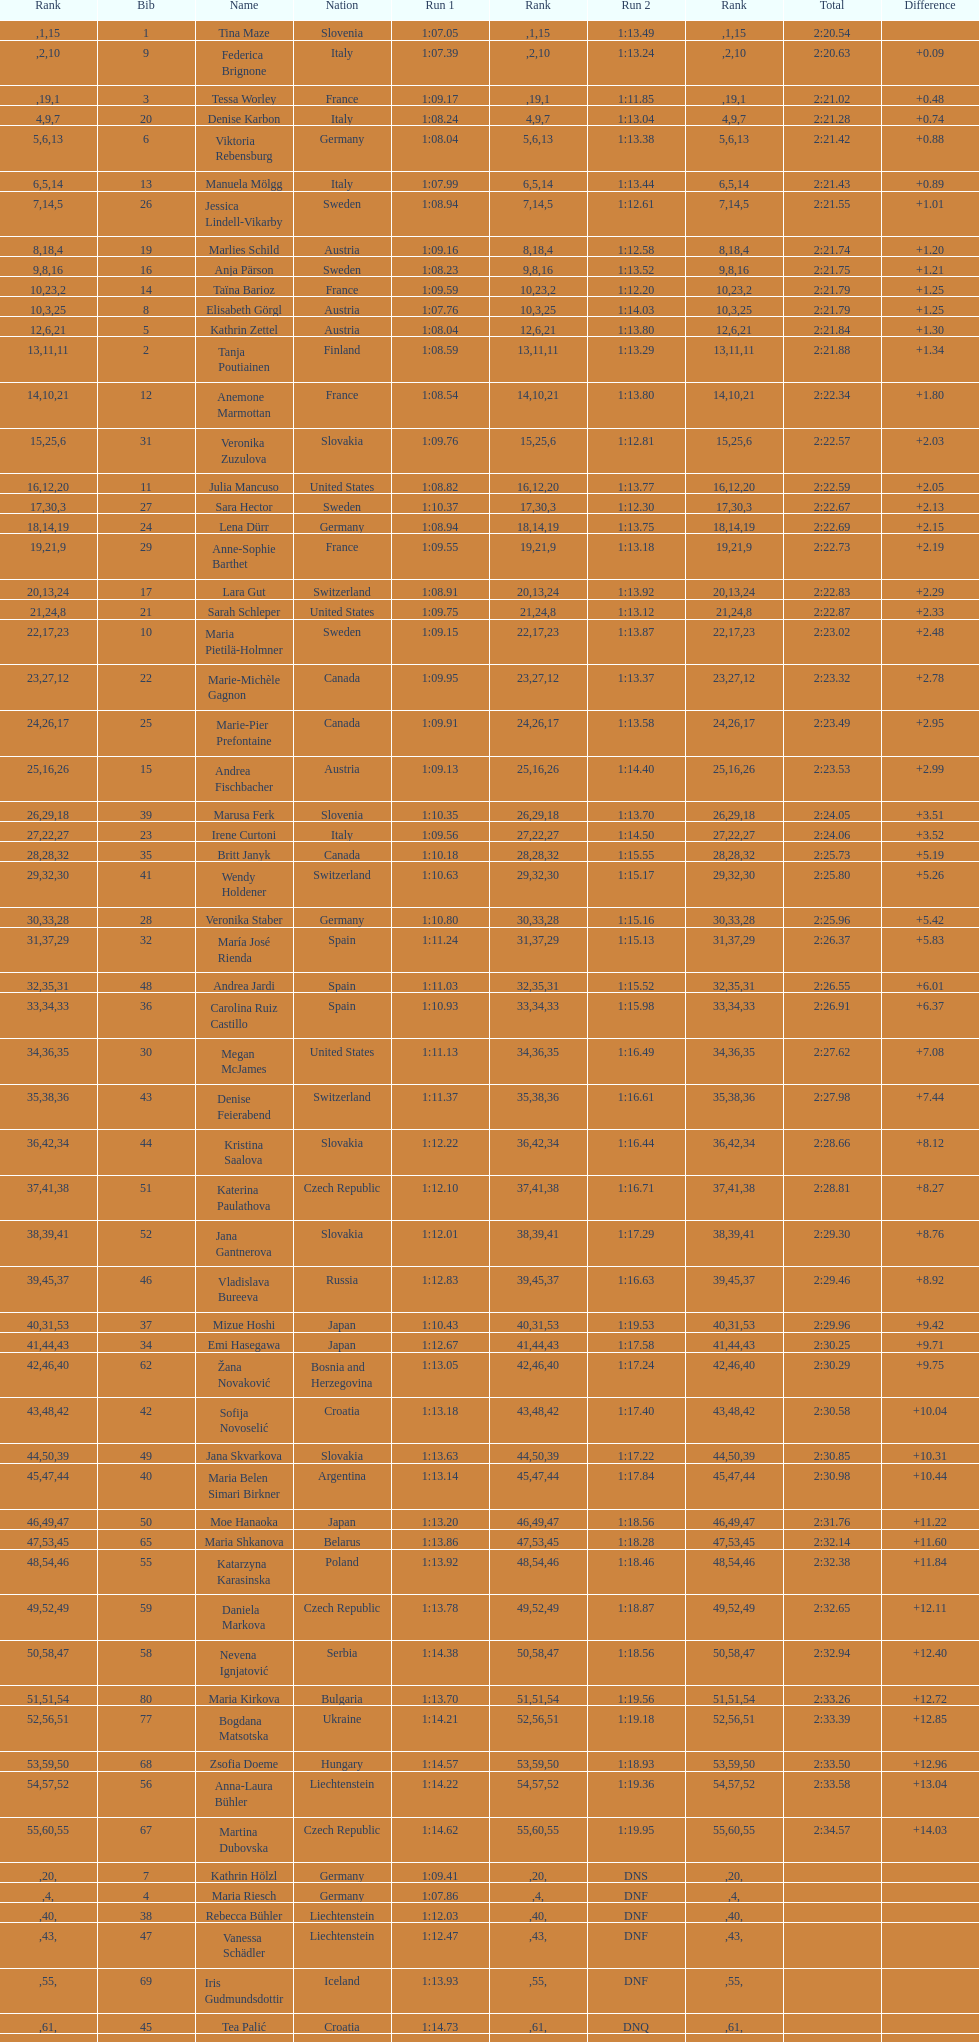How many names are there in total? 116. 